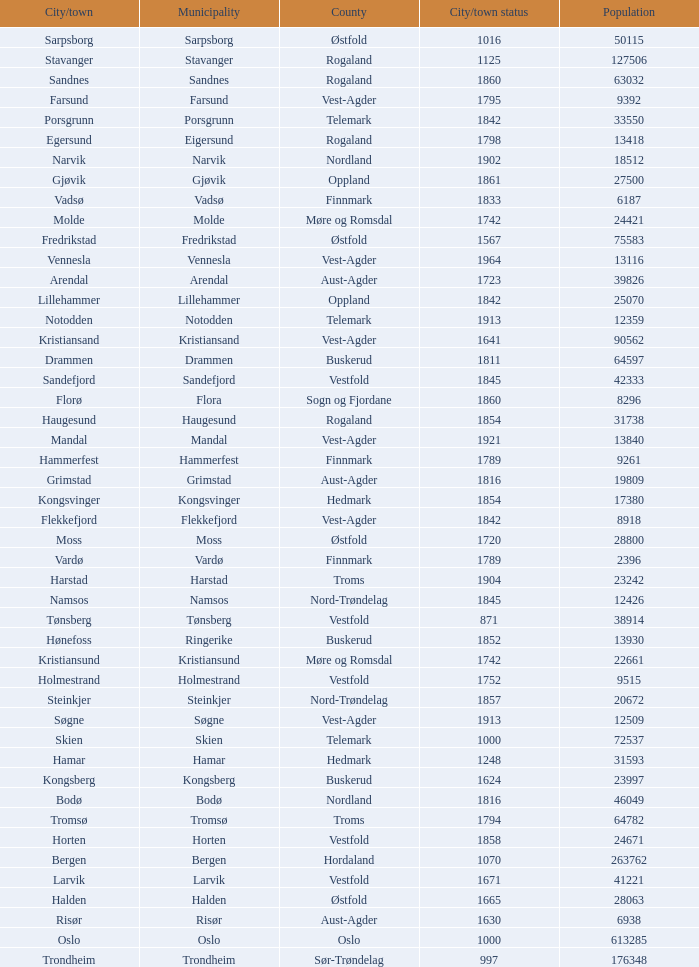Which municipalities located in the county of Finnmark have populations bigger than 6187.0? Hammerfest. 